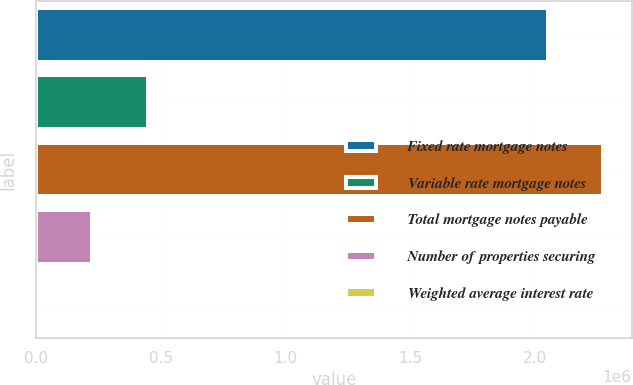Convert chart. <chart><loc_0><loc_0><loc_500><loc_500><bar_chart><fcel>Fixed rate mortgage notes<fcel>Variable rate mortgage notes<fcel>Total mortgage notes payable<fcel>Number of properties securing<fcel>Weighted average interest rate<nl><fcel>2.04958e+06<fcel>446867<fcel>2.27301e+06<fcel>223436<fcel>4.6<nl></chart> 